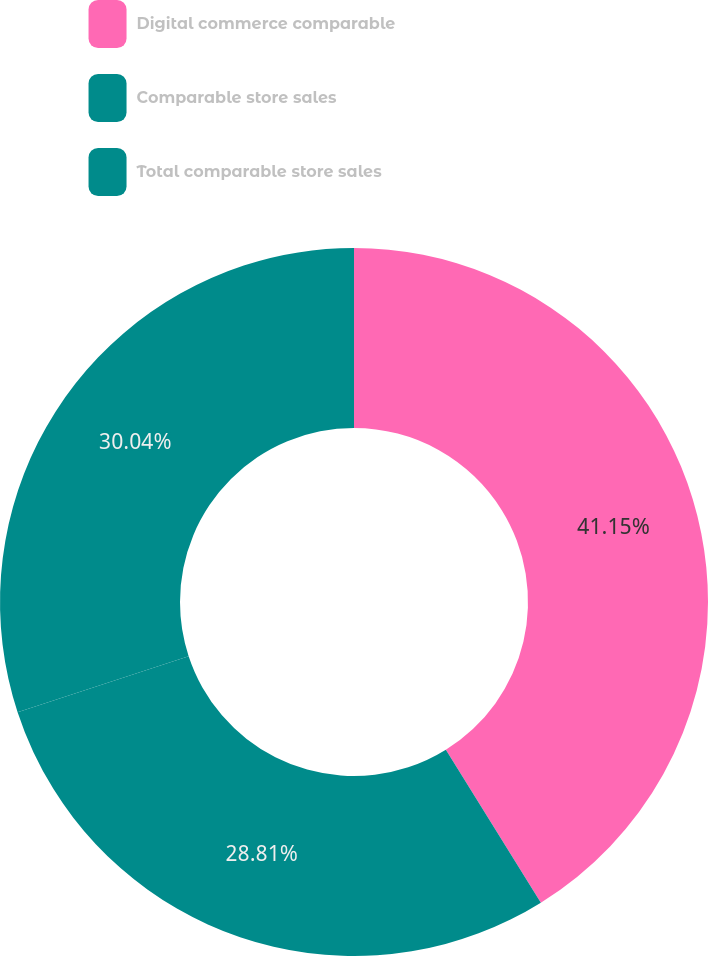Convert chart. <chart><loc_0><loc_0><loc_500><loc_500><pie_chart><fcel>Digital commerce comparable<fcel>Comparable store sales<fcel>Total comparable store sales<nl><fcel>41.15%<fcel>28.81%<fcel>30.04%<nl></chart> 